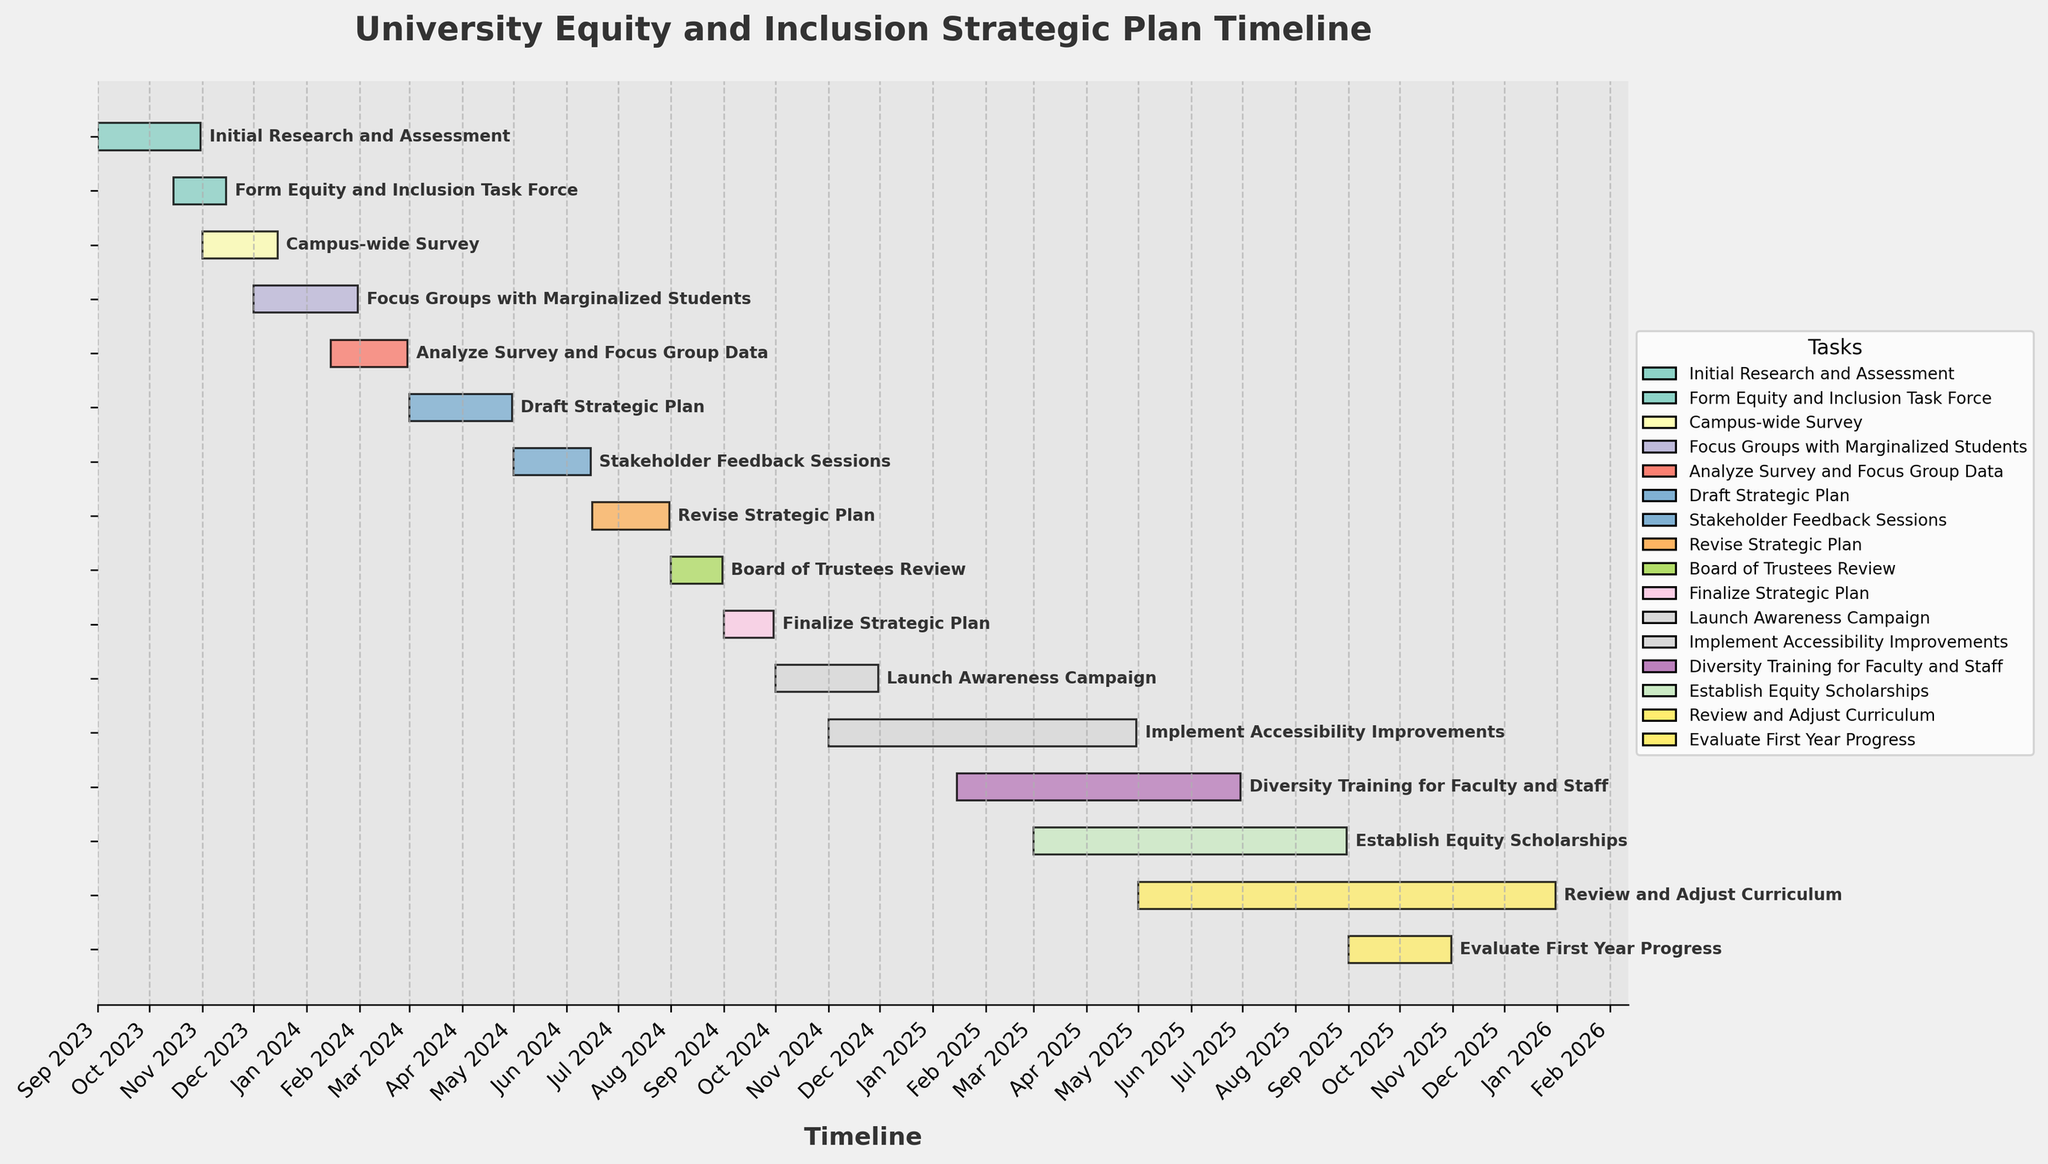When does the "Form Equity and Inclusion Task Force" stage start and end? The Gantt chart shows the start date and end date for each task. For "Form Equity and Inclusion Task Force," it starts on October 15, 2023, and ends on November 15, 2023.
Answer: October 15, 2023, to November 15, 2023 What is the duration of the "Analyze Survey and Focus Group Data" phase? To determine the duration, subtract the start date from the end date. The phase starts on January 15, 2024, and ends on February 29, 2024. This amounts to 45 days.
Answer: 45 days Which task overlaps with the "Focus Groups with Marginalized Students" stage? To find overlapping tasks, locate the "Focus Groups with Marginalized Students" stage and see which tasks' timelines intersect with it. This stage overlaps with "Analyze Survey and Focus Group Data" since both are active in January 2024.
Answer: "Analyze Survey and Focus Group Data" How many tasks are scheduled between September 2023 and December 2023? Check the tasks with start and end dates falling within September 2023 and December 2023. The tasks are "Initial Research and Assessment," "Form Equity and Inclusion Task Force," and "Campus-wide Survey." Additionally, "Focus Groups with Marginalized Students" starts in December 2023. That's a total of 4 tasks.
Answer: 4 tasks When does the "Draft Strategic Plan" phase start relative to the "Analyze Survey and Focus Group Data" phase? The "Analyze Survey and Focus Group Data" phase ends on February 29, 2024, and the "Draft Strategic Plan" phase starts on March 1, 2024. Therefore, the "Draft Strategic Plan" phase starts immediately after the "Analyze Survey and Focus Group Data" phase ends.
Answer: Immediately after Which phase has the longest duration? Look for the task with the largest time span between start and end dates. "Implement Accessibility Improvements" spans from November 1, 2024, to April 30, 2025, which is 182 days, making it the longest duration.
Answer: "Implement Accessibility Improvements" Are there any phases that start in January 2025? Check the start dates of all tasks to see if any begin in January 2025. "Diversity Training for Faculty and Staff" starts on January 15, 2025.
Answer: "Diversity Training for Faculty and Staff" How many tasks are scheduled to be active in June 2024? Identify tasks that have timelines covering June 2024. These include "Stakeholder Feedback Sessions" and "Revise Strategic Plan." So, there are 2 tasks active in June 2024.
Answer: 2 tasks Which tasks are completed before the end of 2023? Look for tasks with end dates in 2023. The tasks "Initial Research and Assessment," "Form Equity and Inclusion Task Force," and "Campus-wide Survey" are all completed before the end of 2023.
Answer: "Initial Research and Assessment," "Form Equity and Inclusion Task Force," "Campus-wide Survey" When does the "Evaluate First Year Progress" stage occur? Locate the "Evaluate First Year Progress" stage on the Gantt chart. It starts on September 1, 2025, and ends on October 31, 2025.
Answer: September 1, 2025, to October 31, 2025 